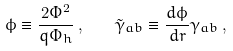Convert formula to latex. <formula><loc_0><loc_0><loc_500><loc_500>\phi \equiv \frac { 2 \Phi ^ { 2 } } { q \Phi _ { h } } \, , \quad \tilde { \gamma } _ { a b } \equiv \frac { d \phi } { d r } \gamma _ { a b } \, ,</formula> 